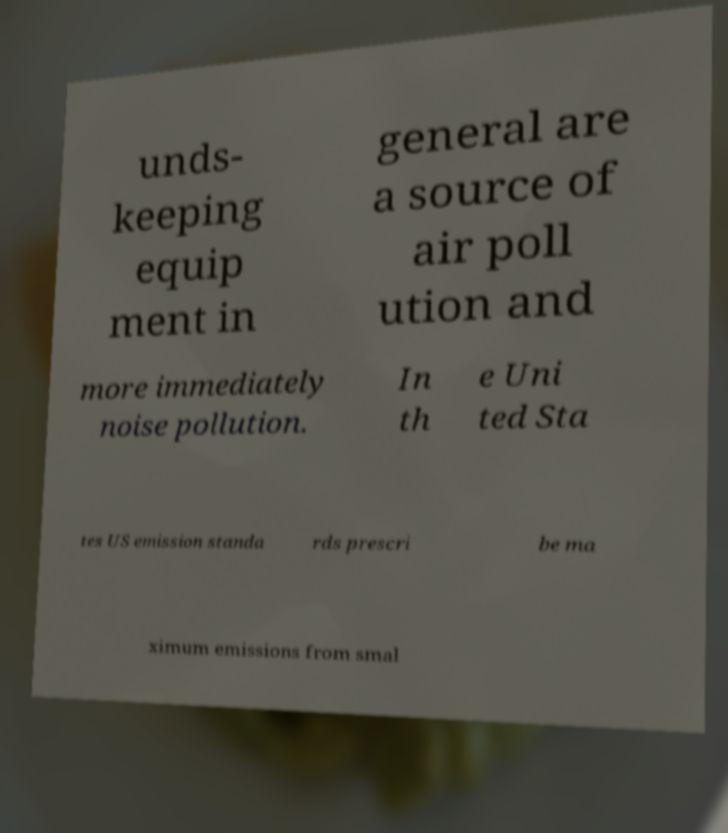Can you accurately transcribe the text from the provided image for me? unds- keeping equip ment in general are a source of air poll ution and more immediately noise pollution. In th e Uni ted Sta tes US emission standa rds prescri be ma ximum emissions from smal 